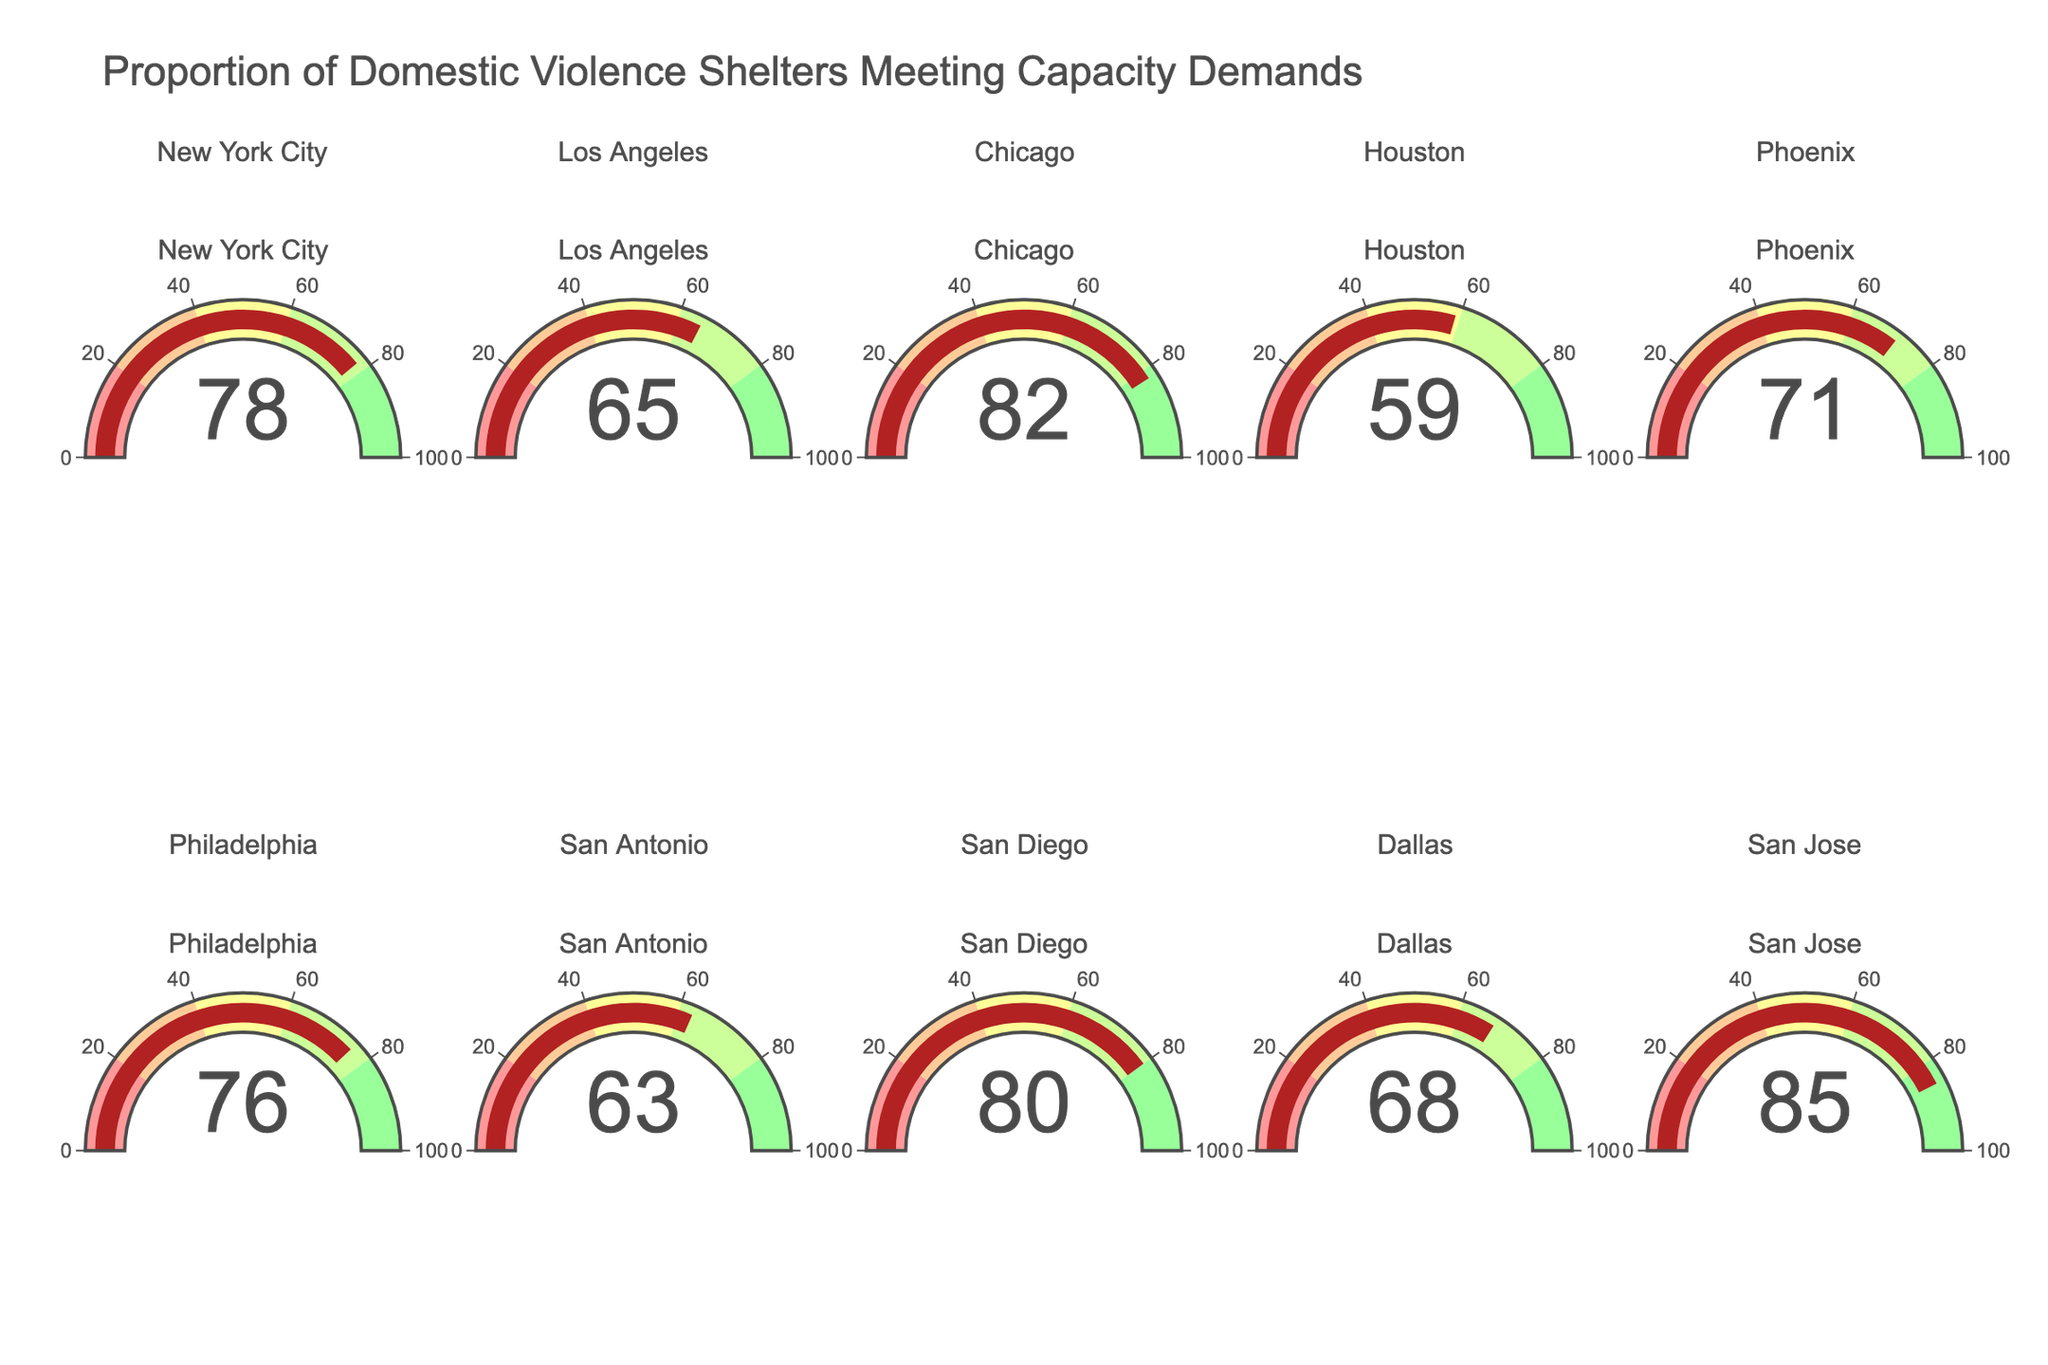Which city has the highest proportion of domestic violence shelters meeting capacity demands? The gauge for San Jose shows the highest value at 85%.
Answer: San Jose Which city has the lowest proportion of domestic violence shelters meeting capacity demands? The gauge for Houston shows the lowest value at 59%.
Answer: Houston How many cities have shelters that meet more than 70% of their capacity demands? By checking the values for each city: New York City (78%), Chicago (82%), Phoenix (71%), Philadelphia (76%), San Diego (80%), and San Jose (85%), there are 6 cities meeting more than 70%.
Answer: 6 Which city's shelters are closer to meeting two-thirds (approximately 66.67%) of their capacity demands? Dallas shows a value of 68%, which is closest to two-thirds of 100.
Answer: Dallas What is the average proportion of shelters meeting their capacity demands across all cities? Sum of percentages (78+65+82+59+71+76+63+80+68+85) = 727. Divide by 10 cities: 727/10 = 72.7%.
Answer: 72.7% Which cities have a proportion of shelters meeting capacity demands between 60% and 70%? Checking the gauges, Los Angeles (65%), Phoenix (71%), and Dallas (68%) fall in this range.
Answer: Los Angeles, Phoenix, Dallas Is there any city where shelters meet less than 60% of capacity demands? The gauges show that only Houston (59%) meets this criterion.
Answer: Houston Which city’s shelters are the closest to meeting 80% of their capacity demands? Comparing values, New York City is at 78%, which is closest to 80%.
Answer: New York City If the goal is to have shelters meet at least 75% of their capacity demands, which cities are currently meeting or exceeding this goal? Gauges for New York City (78%), Chicago (82%), Philadelphia (76%), San Diego (80%), and San Jose (85%) show they are meeting or exceeding 75%.
Answer: New York City, Chicago, Philadelphia, San Diego, San Jose 